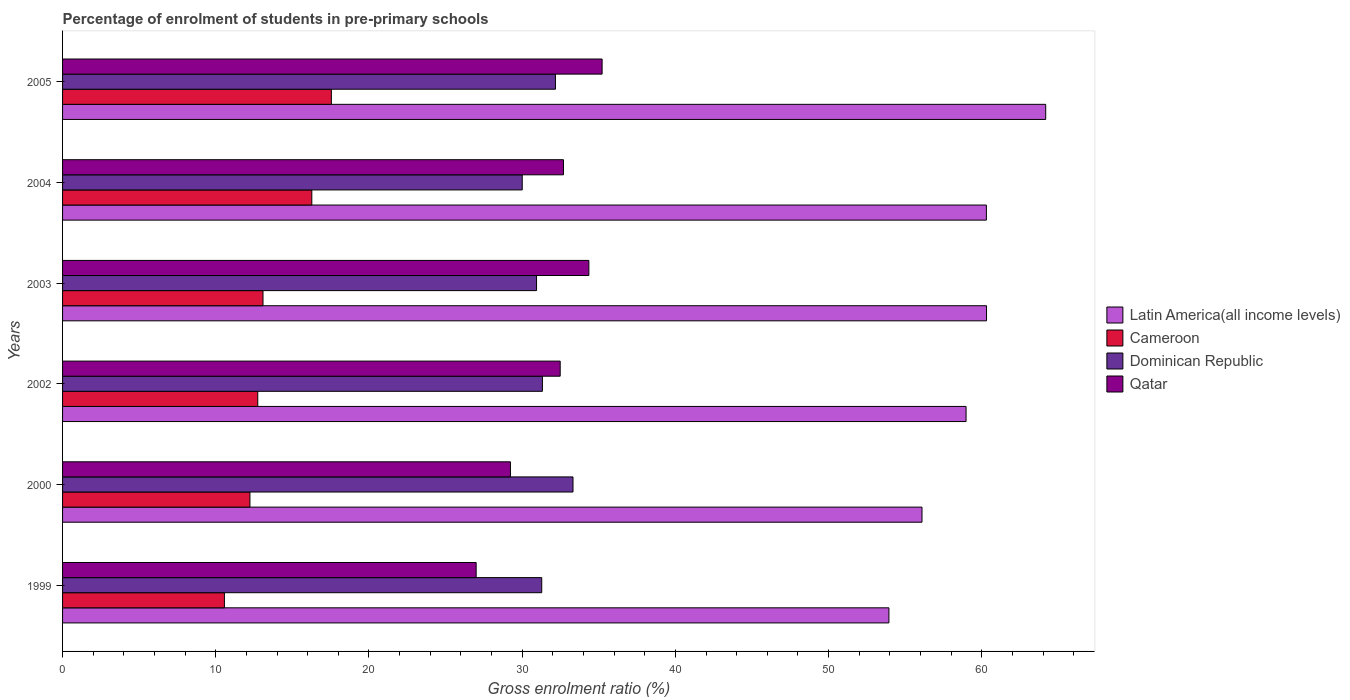How many groups of bars are there?
Your answer should be very brief. 6. Are the number of bars per tick equal to the number of legend labels?
Offer a terse response. Yes. Are the number of bars on each tick of the Y-axis equal?
Your answer should be compact. Yes. How many bars are there on the 1st tick from the top?
Offer a very short reply. 4. How many bars are there on the 1st tick from the bottom?
Provide a succinct answer. 4. What is the label of the 4th group of bars from the top?
Offer a very short reply. 2002. In how many cases, is the number of bars for a given year not equal to the number of legend labels?
Ensure brevity in your answer.  0. What is the percentage of students enrolled in pre-primary schools in Cameroon in 1999?
Ensure brevity in your answer.  10.56. Across all years, what is the maximum percentage of students enrolled in pre-primary schools in Dominican Republic?
Make the answer very short. 33.32. Across all years, what is the minimum percentage of students enrolled in pre-primary schools in Latin America(all income levels)?
Offer a very short reply. 53.94. What is the total percentage of students enrolled in pre-primary schools in Latin America(all income levels) in the graph?
Ensure brevity in your answer.  353.81. What is the difference between the percentage of students enrolled in pre-primary schools in Cameroon in 1999 and that in 2000?
Offer a terse response. -1.67. What is the difference between the percentage of students enrolled in pre-primary schools in Cameroon in 2005 and the percentage of students enrolled in pre-primary schools in Qatar in 2003?
Give a very brief answer. -16.81. What is the average percentage of students enrolled in pre-primary schools in Dominican Republic per year?
Your response must be concise. 31.51. In the year 2002, what is the difference between the percentage of students enrolled in pre-primary schools in Latin America(all income levels) and percentage of students enrolled in pre-primary schools in Cameroon?
Give a very brief answer. 46.23. In how many years, is the percentage of students enrolled in pre-primary schools in Latin America(all income levels) greater than 62 %?
Keep it short and to the point. 1. What is the ratio of the percentage of students enrolled in pre-primary schools in Latin America(all income levels) in 1999 to that in 2000?
Make the answer very short. 0.96. Is the difference between the percentage of students enrolled in pre-primary schools in Latin America(all income levels) in 1999 and 2002 greater than the difference between the percentage of students enrolled in pre-primary schools in Cameroon in 1999 and 2002?
Your answer should be very brief. No. What is the difference between the highest and the second highest percentage of students enrolled in pre-primary schools in Dominican Republic?
Provide a succinct answer. 1.15. What is the difference between the highest and the lowest percentage of students enrolled in pre-primary schools in Latin America(all income levels)?
Your answer should be very brief. 10.23. In how many years, is the percentage of students enrolled in pre-primary schools in Latin America(all income levels) greater than the average percentage of students enrolled in pre-primary schools in Latin America(all income levels) taken over all years?
Keep it short and to the point. 4. Is it the case that in every year, the sum of the percentage of students enrolled in pre-primary schools in Dominican Republic and percentage of students enrolled in pre-primary schools in Cameroon is greater than the sum of percentage of students enrolled in pre-primary schools in Qatar and percentage of students enrolled in pre-primary schools in Latin America(all income levels)?
Keep it short and to the point. Yes. What does the 2nd bar from the top in 2002 represents?
Make the answer very short. Dominican Republic. What does the 1st bar from the bottom in 2003 represents?
Offer a terse response. Latin America(all income levels). How many years are there in the graph?
Make the answer very short. 6. What is the difference between two consecutive major ticks on the X-axis?
Offer a terse response. 10. Are the values on the major ticks of X-axis written in scientific E-notation?
Provide a short and direct response. No. Does the graph contain any zero values?
Provide a succinct answer. No. What is the title of the graph?
Your answer should be very brief. Percentage of enrolment of students in pre-primary schools. What is the label or title of the X-axis?
Your answer should be compact. Gross enrolment ratio (%). What is the Gross enrolment ratio (%) in Latin America(all income levels) in 1999?
Your answer should be compact. 53.94. What is the Gross enrolment ratio (%) of Cameroon in 1999?
Offer a very short reply. 10.56. What is the Gross enrolment ratio (%) in Dominican Republic in 1999?
Provide a short and direct response. 31.28. What is the Gross enrolment ratio (%) of Qatar in 1999?
Keep it short and to the point. 27. What is the Gross enrolment ratio (%) in Latin America(all income levels) in 2000?
Make the answer very short. 56.1. What is the Gross enrolment ratio (%) in Cameroon in 2000?
Make the answer very short. 12.23. What is the Gross enrolment ratio (%) of Dominican Republic in 2000?
Provide a short and direct response. 33.32. What is the Gross enrolment ratio (%) of Qatar in 2000?
Offer a very short reply. 29.23. What is the Gross enrolment ratio (%) of Latin America(all income levels) in 2002?
Ensure brevity in your answer.  58.98. What is the Gross enrolment ratio (%) in Cameroon in 2002?
Offer a terse response. 12.74. What is the Gross enrolment ratio (%) in Dominican Republic in 2002?
Your answer should be very brief. 31.32. What is the Gross enrolment ratio (%) in Qatar in 2002?
Your answer should be very brief. 32.48. What is the Gross enrolment ratio (%) of Latin America(all income levels) in 2003?
Your answer should be very brief. 60.31. What is the Gross enrolment ratio (%) of Cameroon in 2003?
Your response must be concise. 13.08. What is the Gross enrolment ratio (%) in Dominican Republic in 2003?
Offer a terse response. 30.94. What is the Gross enrolment ratio (%) of Qatar in 2003?
Your answer should be compact. 34.35. What is the Gross enrolment ratio (%) in Latin America(all income levels) in 2004?
Give a very brief answer. 60.3. What is the Gross enrolment ratio (%) of Cameroon in 2004?
Offer a very short reply. 16.27. What is the Gross enrolment ratio (%) of Dominican Republic in 2004?
Your answer should be compact. 30. What is the Gross enrolment ratio (%) of Qatar in 2004?
Offer a terse response. 32.7. What is the Gross enrolment ratio (%) of Latin America(all income levels) in 2005?
Keep it short and to the point. 64.17. What is the Gross enrolment ratio (%) in Cameroon in 2005?
Offer a very short reply. 17.55. What is the Gross enrolment ratio (%) of Dominican Republic in 2005?
Provide a succinct answer. 32.17. What is the Gross enrolment ratio (%) in Qatar in 2005?
Keep it short and to the point. 35.22. Across all years, what is the maximum Gross enrolment ratio (%) of Latin America(all income levels)?
Offer a very short reply. 64.17. Across all years, what is the maximum Gross enrolment ratio (%) in Cameroon?
Offer a terse response. 17.55. Across all years, what is the maximum Gross enrolment ratio (%) in Dominican Republic?
Provide a succinct answer. 33.32. Across all years, what is the maximum Gross enrolment ratio (%) in Qatar?
Your answer should be very brief. 35.22. Across all years, what is the minimum Gross enrolment ratio (%) of Latin America(all income levels)?
Keep it short and to the point. 53.94. Across all years, what is the minimum Gross enrolment ratio (%) of Cameroon?
Offer a terse response. 10.56. Across all years, what is the minimum Gross enrolment ratio (%) of Dominican Republic?
Provide a succinct answer. 30. Across all years, what is the minimum Gross enrolment ratio (%) in Qatar?
Your answer should be very brief. 27. What is the total Gross enrolment ratio (%) in Latin America(all income levels) in the graph?
Offer a terse response. 353.81. What is the total Gross enrolment ratio (%) in Cameroon in the graph?
Provide a succinct answer. 82.44. What is the total Gross enrolment ratio (%) in Dominican Republic in the graph?
Make the answer very short. 189.04. What is the total Gross enrolment ratio (%) of Qatar in the graph?
Give a very brief answer. 190.98. What is the difference between the Gross enrolment ratio (%) in Latin America(all income levels) in 1999 and that in 2000?
Your answer should be very brief. -2.16. What is the difference between the Gross enrolment ratio (%) of Cameroon in 1999 and that in 2000?
Make the answer very short. -1.67. What is the difference between the Gross enrolment ratio (%) of Dominican Republic in 1999 and that in 2000?
Your response must be concise. -2.04. What is the difference between the Gross enrolment ratio (%) of Qatar in 1999 and that in 2000?
Ensure brevity in your answer.  -2.24. What is the difference between the Gross enrolment ratio (%) in Latin America(all income levels) in 1999 and that in 2002?
Your response must be concise. -5.03. What is the difference between the Gross enrolment ratio (%) of Cameroon in 1999 and that in 2002?
Provide a succinct answer. -2.18. What is the difference between the Gross enrolment ratio (%) of Dominican Republic in 1999 and that in 2002?
Your answer should be compact. -0.04. What is the difference between the Gross enrolment ratio (%) of Qatar in 1999 and that in 2002?
Offer a very short reply. -5.48. What is the difference between the Gross enrolment ratio (%) in Latin America(all income levels) in 1999 and that in 2003?
Provide a succinct answer. -6.37. What is the difference between the Gross enrolment ratio (%) in Cameroon in 1999 and that in 2003?
Your response must be concise. -2.52. What is the difference between the Gross enrolment ratio (%) of Dominican Republic in 1999 and that in 2003?
Offer a very short reply. 0.34. What is the difference between the Gross enrolment ratio (%) of Qatar in 1999 and that in 2003?
Your answer should be very brief. -7.36. What is the difference between the Gross enrolment ratio (%) of Latin America(all income levels) in 1999 and that in 2004?
Give a very brief answer. -6.36. What is the difference between the Gross enrolment ratio (%) in Cameroon in 1999 and that in 2004?
Offer a very short reply. -5.7. What is the difference between the Gross enrolment ratio (%) of Dominican Republic in 1999 and that in 2004?
Provide a short and direct response. 1.27. What is the difference between the Gross enrolment ratio (%) of Qatar in 1999 and that in 2004?
Make the answer very short. -5.7. What is the difference between the Gross enrolment ratio (%) of Latin America(all income levels) in 1999 and that in 2005?
Provide a succinct answer. -10.23. What is the difference between the Gross enrolment ratio (%) in Cameroon in 1999 and that in 2005?
Make the answer very short. -6.98. What is the difference between the Gross enrolment ratio (%) of Dominican Republic in 1999 and that in 2005?
Offer a terse response. -0.9. What is the difference between the Gross enrolment ratio (%) in Qatar in 1999 and that in 2005?
Your answer should be compact. -8.22. What is the difference between the Gross enrolment ratio (%) in Latin America(all income levels) in 2000 and that in 2002?
Keep it short and to the point. -2.88. What is the difference between the Gross enrolment ratio (%) in Cameroon in 2000 and that in 2002?
Offer a terse response. -0.51. What is the difference between the Gross enrolment ratio (%) in Dominican Republic in 2000 and that in 2002?
Provide a succinct answer. 2. What is the difference between the Gross enrolment ratio (%) in Qatar in 2000 and that in 2002?
Your response must be concise. -3.25. What is the difference between the Gross enrolment ratio (%) of Latin America(all income levels) in 2000 and that in 2003?
Give a very brief answer. -4.21. What is the difference between the Gross enrolment ratio (%) in Cameroon in 2000 and that in 2003?
Your response must be concise. -0.85. What is the difference between the Gross enrolment ratio (%) in Dominican Republic in 2000 and that in 2003?
Provide a short and direct response. 2.38. What is the difference between the Gross enrolment ratio (%) in Qatar in 2000 and that in 2003?
Your response must be concise. -5.12. What is the difference between the Gross enrolment ratio (%) of Latin America(all income levels) in 2000 and that in 2004?
Provide a short and direct response. -4.2. What is the difference between the Gross enrolment ratio (%) in Cameroon in 2000 and that in 2004?
Offer a very short reply. -4.04. What is the difference between the Gross enrolment ratio (%) in Dominican Republic in 2000 and that in 2004?
Your response must be concise. 3.31. What is the difference between the Gross enrolment ratio (%) in Qatar in 2000 and that in 2004?
Keep it short and to the point. -3.46. What is the difference between the Gross enrolment ratio (%) in Latin America(all income levels) in 2000 and that in 2005?
Give a very brief answer. -8.08. What is the difference between the Gross enrolment ratio (%) of Cameroon in 2000 and that in 2005?
Your response must be concise. -5.32. What is the difference between the Gross enrolment ratio (%) of Dominican Republic in 2000 and that in 2005?
Provide a short and direct response. 1.15. What is the difference between the Gross enrolment ratio (%) of Qatar in 2000 and that in 2005?
Provide a short and direct response. -5.98. What is the difference between the Gross enrolment ratio (%) of Latin America(all income levels) in 2002 and that in 2003?
Give a very brief answer. -1.34. What is the difference between the Gross enrolment ratio (%) in Cameroon in 2002 and that in 2003?
Ensure brevity in your answer.  -0.34. What is the difference between the Gross enrolment ratio (%) in Dominican Republic in 2002 and that in 2003?
Offer a terse response. 0.38. What is the difference between the Gross enrolment ratio (%) of Qatar in 2002 and that in 2003?
Your answer should be compact. -1.87. What is the difference between the Gross enrolment ratio (%) in Latin America(all income levels) in 2002 and that in 2004?
Your response must be concise. -1.33. What is the difference between the Gross enrolment ratio (%) in Cameroon in 2002 and that in 2004?
Provide a short and direct response. -3.53. What is the difference between the Gross enrolment ratio (%) in Dominican Republic in 2002 and that in 2004?
Your answer should be very brief. 1.32. What is the difference between the Gross enrolment ratio (%) in Qatar in 2002 and that in 2004?
Keep it short and to the point. -0.21. What is the difference between the Gross enrolment ratio (%) in Latin America(all income levels) in 2002 and that in 2005?
Give a very brief answer. -5.2. What is the difference between the Gross enrolment ratio (%) of Cameroon in 2002 and that in 2005?
Make the answer very short. -4.8. What is the difference between the Gross enrolment ratio (%) in Dominican Republic in 2002 and that in 2005?
Make the answer very short. -0.85. What is the difference between the Gross enrolment ratio (%) in Qatar in 2002 and that in 2005?
Provide a short and direct response. -2.74. What is the difference between the Gross enrolment ratio (%) of Latin America(all income levels) in 2003 and that in 2004?
Offer a terse response. 0.01. What is the difference between the Gross enrolment ratio (%) of Cameroon in 2003 and that in 2004?
Keep it short and to the point. -3.19. What is the difference between the Gross enrolment ratio (%) of Dominican Republic in 2003 and that in 2004?
Your answer should be very brief. 0.93. What is the difference between the Gross enrolment ratio (%) of Qatar in 2003 and that in 2004?
Provide a short and direct response. 1.66. What is the difference between the Gross enrolment ratio (%) in Latin America(all income levels) in 2003 and that in 2005?
Your response must be concise. -3.86. What is the difference between the Gross enrolment ratio (%) of Cameroon in 2003 and that in 2005?
Provide a short and direct response. -4.46. What is the difference between the Gross enrolment ratio (%) of Dominican Republic in 2003 and that in 2005?
Provide a short and direct response. -1.23. What is the difference between the Gross enrolment ratio (%) of Qatar in 2003 and that in 2005?
Give a very brief answer. -0.86. What is the difference between the Gross enrolment ratio (%) in Latin America(all income levels) in 2004 and that in 2005?
Ensure brevity in your answer.  -3.87. What is the difference between the Gross enrolment ratio (%) in Cameroon in 2004 and that in 2005?
Provide a succinct answer. -1.28. What is the difference between the Gross enrolment ratio (%) in Dominican Republic in 2004 and that in 2005?
Provide a succinct answer. -2.17. What is the difference between the Gross enrolment ratio (%) of Qatar in 2004 and that in 2005?
Your answer should be very brief. -2.52. What is the difference between the Gross enrolment ratio (%) of Latin America(all income levels) in 1999 and the Gross enrolment ratio (%) of Cameroon in 2000?
Your response must be concise. 41.71. What is the difference between the Gross enrolment ratio (%) of Latin America(all income levels) in 1999 and the Gross enrolment ratio (%) of Dominican Republic in 2000?
Give a very brief answer. 20.62. What is the difference between the Gross enrolment ratio (%) of Latin America(all income levels) in 1999 and the Gross enrolment ratio (%) of Qatar in 2000?
Your answer should be compact. 24.71. What is the difference between the Gross enrolment ratio (%) of Cameroon in 1999 and the Gross enrolment ratio (%) of Dominican Republic in 2000?
Make the answer very short. -22.75. What is the difference between the Gross enrolment ratio (%) in Cameroon in 1999 and the Gross enrolment ratio (%) in Qatar in 2000?
Give a very brief answer. -18.67. What is the difference between the Gross enrolment ratio (%) of Dominican Republic in 1999 and the Gross enrolment ratio (%) of Qatar in 2000?
Your answer should be compact. 2.04. What is the difference between the Gross enrolment ratio (%) in Latin America(all income levels) in 1999 and the Gross enrolment ratio (%) in Cameroon in 2002?
Your answer should be very brief. 41.2. What is the difference between the Gross enrolment ratio (%) in Latin America(all income levels) in 1999 and the Gross enrolment ratio (%) in Dominican Republic in 2002?
Offer a terse response. 22.62. What is the difference between the Gross enrolment ratio (%) of Latin America(all income levels) in 1999 and the Gross enrolment ratio (%) of Qatar in 2002?
Offer a terse response. 21.46. What is the difference between the Gross enrolment ratio (%) in Cameroon in 1999 and the Gross enrolment ratio (%) in Dominican Republic in 2002?
Provide a succinct answer. -20.76. What is the difference between the Gross enrolment ratio (%) in Cameroon in 1999 and the Gross enrolment ratio (%) in Qatar in 2002?
Ensure brevity in your answer.  -21.92. What is the difference between the Gross enrolment ratio (%) in Dominican Republic in 1999 and the Gross enrolment ratio (%) in Qatar in 2002?
Ensure brevity in your answer.  -1.2. What is the difference between the Gross enrolment ratio (%) of Latin America(all income levels) in 1999 and the Gross enrolment ratio (%) of Cameroon in 2003?
Provide a short and direct response. 40.86. What is the difference between the Gross enrolment ratio (%) in Latin America(all income levels) in 1999 and the Gross enrolment ratio (%) in Dominican Republic in 2003?
Provide a short and direct response. 23. What is the difference between the Gross enrolment ratio (%) of Latin America(all income levels) in 1999 and the Gross enrolment ratio (%) of Qatar in 2003?
Make the answer very short. 19.59. What is the difference between the Gross enrolment ratio (%) in Cameroon in 1999 and the Gross enrolment ratio (%) in Dominican Republic in 2003?
Keep it short and to the point. -20.37. What is the difference between the Gross enrolment ratio (%) in Cameroon in 1999 and the Gross enrolment ratio (%) in Qatar in 2003?
Provide a short and direct response. -23.79. What is the difference between the Gross enrolment ratio (%) of Dominican Republic in 1999 and the Gross enrolment ratio (%) of Qatar in 2003?
Keep it short and to the point. -3.08. What is the difference between the Gross enrolment ratio (%) of Latin America(all income levels) in 1999 and the Gross enrolment ratio (%) of Cameroon in 2004?
Offer a very short reply. 37.67. What is the difference between the Gross enrolment ratio (%) in Latin America(all income levels) in 1999 and the Gross enrolment ratio (%) in Dominican Republic in 2004?
Offer a terse response. 23.94. What is the difference between the Gross enrolment ratio (%) in Latin America(all income levels) in 1999 and the Gross enrolment ratio (%) in Qatar in 2004?
Your response must be concise. 21.24. What is the difference between the Gross enrolment ratio (%) in Cameroon in 1999 and the Gross enrolment ratio (%) in Dominican Republic in 2004?
Keep it short and to the point. -19.44. What is the difference between the Gross enrolment ratio (%) of Cameroon in 1999 and the Gross enrolment ratio (%) of Qatar in 2004?
Offer a terse response. -22.13. What is the difference between the Gross enrolment ratio (%) of Dominican Republic in 1999 and the Gross enrolment ratio (%) of Qatar in 2004?
Give a very brief answer. -1.42. What is the difference between the Gross enrolment ratio (%) of Latin America(all income levels) in 1999 and the Gross enrolment ratio (%) of Cameroon in 2005?
Give a very brief answer. 36.4. What is the difference between the Gross enrolment ratio (%) of Latin America(all income levels) in 1999 and the Gross enrolment ratio (%) of Dominican Republic in 2005?
Offer a very short reply. 21.77. What is the difference between the Gross enrolment ratio (%) of Latin America(all income levels) in 1999 and the Gross enrolment ratio (%) of Qatar in 2005?
Provide a succinct answer. 18.72. What is the difference between the Gross enrolment ratio (%) of Cameroon in 1999 and the Gross enrolment ratio (%) of Dominican Republic in 2005?
Keep it short and to the point. -21.61. What is the difference between the Gross enrolment ratio (%) in Cameroon in 1999 and the Gross enrolment ratio (%) in Qatar in 2005?
Ensure brevity in your answer.  -24.65. What is the difference between the Gross enrolment ratio (%) in Dominican Republic in 1999 and the Gross enrolment ratio (%) in Qatar in 2005?
Keep it short and to the point. -3.94. What is the difference between the Gross enrolment ratio (%) of Latin America(all income levels) in 2000 and the Gross enrolment ratio (%) of Cameroon in 2002?
Make the answer very short. 43.36. What is the difference between the Gross enrolment ratio (%) in Latin America(all income levels) in 2000 and the Gross enrolment ratio (%) in Dominican Republic in 2002?
Provide a short and direct response. 24.78. What is the difference between the Gross enrolment ratio (%) of Latin America(all income levels) in 2000 and the Gross enrolment ratio (%) of Qatar in 2002?
Offer a very short reply. 23.62. What is the difference between the Gross enrolment ratio (%) in Cameroon in 2000 and the Gross enrolment ratio (%) in Dominican Republic in 2002?
Your answer should be compact. -19.09. What is the difference between the Gross enrolment ratio (%) in Cameroon in 2000 and the Gross enrolment ratio (%) in Qatar in 2002?
Give a very brief answer. -20.25. What is the difference between the Gross enrolment ratio (%) in Dominican Republic in 2000 and the Gross enrolment ratio (%) in Qatar in 2002?
Keep it short and to the point. 0.84. What is the difference between the Gross enrolment ratio (%) of Latin America(all income levels) in 2000 and the Gross enrolment ratio (%) of Cameroon in 2003?
Give a very brief answer. 43.02. What is the difference between the Gross enrolment ratio (%) of Latin America(all income levels) in 2000 and the Gross enrolment ratio (%) of Dominican Republic in 2003?
Provide a short and direct response. 25.16. What is the difference between the Gross enrolment ratio (%) in Latin America(all income levels) in 2000 and the Gross enrolment ratio (%) in Qatar in 2003?
Your answer should be compact. 21.74. What is the difference between the Gross enrolment ratio (%) of Cameroon in 2000 and the Gross enrolment ratio (%) of Dominican Republic in 2003?
Keep it short and to the point. -18.71. What is the difference between the Gross enrolment ratio (%) of Cameroon in 2000 and the Gross enrolment ratio (%) of Qatar in 2003?
Your response must be concise. -22.12. What is the difference between the Gross enrolment ratio (%) in Dominican Republic in 2000 and the Gross enrolment ratio (%) in Qatar in 2003?
Your response must be concise. -1.04. What is the difference between the Gross enrolment ratio (%) in Latin America(all income levels) in 2000 and the Gross enrolment ratio (%) in Cameroon in 2004?
Your response must be concise. 39.83. What is the difference between the Gross enrolment ratio (%) in Latin America(all income levels) in 2000 and the Gross enrolment ratio (%) in Dominican Republic in 2004?
Your response must be concise. 26.09. What is the difference between the Gross enrolment ratio (%) in Latin America(all income levels) in 2000 and the Gross enrolment ratio (%) in Qatar in 2004?
Make the answer very short. 23.4. What is the difference between the Gross enrolment ratio (%) in Cameroon in 2000 and the Gross enrolment ratio (%) in Dominican Republic in 2004?
Provide a succinct answer. -17.77. What is the difference between the Gross enrolment ratio (%) of Cameroon in 2000 and the Gross enrolment ratio (%) of Qatar in 2004?
Keep it short and to the point. -20.47. What is the difference between the Gross enrolment ratio (%) of Dominican Republic in 2000 and the Gross enrolment ratio (%) of Qatar in 2004?
Offer a terse response. 0.62. What is the difference between the Gross enrolment ratio (%) in Latin America(all income levels) in 2000 and the Gross enrolment ratio (%) in Cameroon in 2005?
Your answer should be compact. 38.55. What is the difference between the Gross enrolment ratio (%) of Latin America(all income levels) in 2000 and the Gross enrolment ratio (%) of Dominican Republic in 2005?
Offer a very short reply. 23.93. What is the difference between the Gross enrolment ratio (%) of Latin America(all income levels) in 2000 and the Gross enrolment ratio (%) of Qatar in 2005?
Your response must be concise. 20.88. What is the difference between the Gross enrolment ratio (%) of Cameroon in 2000 and the Gross enrolment ratio (%) of Dominican Republic in 2005?
Give a very brief answer. -19.94. What is the difference between the Gross enrolment ratio (%) of Cameroon in 2000 and the Gross enrolment ratio (%) of Qatar in 2005?
Offer a terse response. -22.99. What is the difference between the Gross enrolment ratio (%) in Latin America(all income levels) in 2002 and the Gross enrolment ratio (%) in Cameroon in 2003?
Provide a short and direct response. 45.89. What is the difference between the Gross enrolment ratio (%) in Latin America(all income levels) in 2002 and the Gross enrolment ratio (%) in Dominican Republic in 2003?
Keep it short and to the point. 28.04. What is the difference between the Gross enrolment ratio (%) of Latin America(all income levels) in 2002 and the Gross enrolment ratio (%) of Qatar in 2003?
Keep it short and to the point. 24.62. What is the difference between the Gross enrolment ratio (%) in Cameroon in 2002 and the Gross enrolment ratio (%) in Dominican Republic in 2003?
Your answer should be compact. -18.2. What is the difference between the Gross enrolment ratio (%) in Cameroon in 2002 and the Gross enrolment ratio (%) in Qatar in 2003?
Provide a succinct answer. -21.61. What is the difference between the Gross enrolment ratio (%) in Dominican Republic in 2002 and the Gross enrolment ratio (%) in Qatar in 2003?
Give a very brief answer. -3.03. What is the difference between the Gross enrolment ratio (%) of Latin America(all income levels) in 2002 and the Gross enrolment ratio (%) of Cameroon in 2004?
Your response must be concise. 42.71. What is the difference between the Gross enrolment ratio (%) in Latin America(all income levels) in 2002 and the Gross enrolment ratio (%) in Dominican Republic in 2004?
Offer a terse response. 28.97. What is the difference between the Gross enrolment ratio (%) in Latin America(all income levels) in 2002 and the Gross enrolment ratio (%) in Qatar in 2004?
Offer a terse response. 26.28. What is the difference between the Gross enrolment ratio (%) of Cameroon in 2002 and the Gross enrolment ratio (%) of Dominican Republic in 2004?
Ensure brevity in your answer.  -17.26. What is the difference between the Gross enrolment ratio (%) in Cameroon in 2002 and the Gross enrolment ratio (%) in Qatar in 2004?
Make the answer very short. -19.95. What is the difference between the Gross enrolment ratio (%) of Dominican Republic in 2002 and the Gross enrolment ratio (%) of Qatar in 2004?
Provide a short and direct response. -1.37. What is the difference between the Gross enrolment ratio (%) of Latin America(all income levels) in 2002 and the Gross enrolment ratio (%) of Cameroon in 2005?
Give a very brief answer. 41.43. What is the difference between the Gross enrolment ratio (%) in Latin America(all income levels) in 2002 and the Gross enrolment ratio (%) in Dominican Republic in 2005?
Provide a short and direct response. 26.8. What is the difference between the Gross enrolment ratio (%) in Latin America(all income levels) in 2002 and the Gross enrolment ratio (%) in Qatar in 2005?
Provide a short and direct response. 23.76. What is the difference between the Gross enrolment ratio (%) of Cameroon in 2002 and the Gross enrolment ratio (%) of Dominican Republic in 2005?
Offer a very short reply. -19.43. What is the difference between the Gross enrolment ratio (%) in Cameroon in 2002 and the Gross enrolment ratio (%) in Qatar in 2005?
Keep it short and to the point. -22.48. What is the difference between the Gross enrolment ratio (%) of Dominican Republic in 2002 and the Gross enrolment ratio (%) of Qatar in 2005?
Offer a terse response. -3.9. What is the difference between the Gross enrolment ratio (%) in Latin America(all income levels) in 2003 and the Gross enrolment ratio (%) in Cameroon in 2004?
Give a very brief answer. 44.04. What is the difference between the Gross enrolment ratio (%) in Latin America(all income levels) in 2003 and the Gross enrolment ratio (%) in Dominican Republic in 2004?
Ensure brevity in your answer.  30.31. What is the difference between the Gross enrolment ratio (%) of Latin America(all income levels) in 2003 and the Gross enrolment ratio (%) of Qatar in 2004?
Offer a very short reply. 27.62. What is the difference between the Gross enrolment ratio (%) of Cameroon in 2003 and the Gross enrolment ratio (%) of Dominican Republic in 2004?
Your answer should be very brief. -16.92. What is the difference between the Gross enrolment ratio (%) in Cameroon in 2003 and the Gross enrolment ratio (%) in Qatar in 2004?
Your response must be concise. -19.61. What is the difference between the Gross enrolment ratio (%) of Dominican Republic in 2003 and the Gross enrolment ratio (%) of Qatar in 2004?
Your answer should be very brief. -1.76. What is the difference between the Gross enrolment ratio (%) in Latin America(all income levels) in 2003 and the Gross enrolment ratio (%) in Cameroon in 2005?
Offer a terse response. 42.77. What is the difference between the Gross enrolment ratio (%) of Latin America(all income levels) in 2003 and the Gross enrolment ratio (%) of Dominican Republic in 2005?
Provide a succinct answer. 28.14. What is the difference between the Gross enrolment ratio (%) in Latin America(all income levels) in 2003 and the Gross enrolment ratio (%) in Qatar in 2005?
Ensure brevity in your answer.  25.09. What is the difference between the Gross enrolment ratio (%) of Cameroon in 2003 and the Gross enrolment ratio (%) of Dominican Republic in 2005?
Your answer should be very brief. -19.09. What is the difference between the Gross enrolment ratio (%) of Cameroon in 2003 and the Gross enrolment ratio (%) of Qatar in 2005?
Your response must be concise. -22.14. What is the difference between the Gross enrolment ratio (%) in Dominican Republic in 2003 and the Gross enrolment ratio (%) in Qatar in 2005?
Your answer should be very brief. -4.28. What is the difference between the Gross enrolment ratio (%) of Latin America(all income levels) in 2004 and the Gross enrolment ratio (%) of Cameroon in 2005?
Provide a short and direct response. 42.76. What is the difference between the Gross enrolment ratio (%) in Latin America(all income levels) in 2004 and the Gross enrolment ratio (%) in Dominican Republic in 2005?
Offer a very short reply. 28.13. What is the difference between the Gross enrolment ratio (%) in Latin America(all income levels) in 2004 and the Gross enrolment ratio (%) in Qatar in 2005?
Offer a very short reply. 25.08. What is the difference between the Gross enrolment ratio (%) of Cameroon in 2004 and the Gross enrolment ratio (%) of Dominican Republic in 2005?
Your answer should be compact. -15.9. What is the difference between the Gross enrolment ratio (%) of Cameroon in 2004 and the Gross enrolment ratio (%) of Qatar in 2005?
Your answer should be very brief. -18.95. What is the difference between the Gross enrolment ratio (%) in Dominican Republic in 2004 and the Gross enrolment ratio (%) in Qatar in 2005?
Offer a terse response. -5.21. What is the average Gross enrolment ratio (%) of Latin America(all income levels) per year?
Offer a very short reply. 58.97. What is the average Gross enrolment ratio (%) in Cameroon per year?
Provide a succinct answer. 13.74. What is the average Gross enrolment ratio (%) in Dominican Republic per year?
Give a very brief answer. 31.51. What is the average Gross enrolment ratio (%) of Qatar per year?
Offer a terse response. 31.83. In the year 1999, what is the difference between the Gross enrolment ratio (%) of Latin America(all income levels) and Gross enrolment ratio (%) of Cameroon?
Make the answer very short. 43.38. In the year 1999, what is the difference between the Gross enrolment ratio (%) in Latin America(all income levels) and Gross enrolment ratio (%) in Dominican Republic?
Your response must be concise. 22.66. In the year 1999, what is the difference between the Gross enrolment ratio (%) in Latin America(all income levels) and Gross enrolment ratio (%) in Qatar?
Offer a terse response. 26.94. In the year 1999, what is the difference between the Gross enrolment ratio (%) of Cameroon and Gross enrolment ratio (%) of Dominican Republic?
Your answer should be very brief. -20.71. In the year 1999, what is the difference between the Gross enrolment ratio (%) in Cameroon and Gross enrolment ratio (%) in Qatar?
Provide a succinct answer. -16.43. In the year 1999, what is the difference between the Gross enrolment ratio (%) of Dominican Republic and Gross enrolment ratio (%) of Qatar?
Your answer should be very brief. 4.28. In the year 2000, what is the difference between the Gross enrolment ratio (%) of Latin America(all income levels) and Gross enrolment ratio (%) of Cameroon?
Offer a terse response. 43.87. In the year 2000, what is the difference between the Gross enrolment ratio (%) of Latin America(all income levels) and Gross enrolment ratio (%) of Dominican Republic?
Ensure brevity in your answer.  22.78. In the year 2000, what is the difference between the Gross enrolment ratio (%) of Latin America(all income levels) and Gross enrolment ratio (%) of Qatar?
Offer a very short reply. 26.86. In the year 2000, what is the difference between the Gross enrolment ratio (%) of Cameroon and Gross enrolment ratio (%) of Dominican Republic?
Your answer should be very brief. -21.09. In the year 2000, what is the difference between the Gross enrolment ratio (%) of Cameroon and Gross enrolment ratio (%) of Qatar?
Provide a succinct answer. -17. In the year 2000, what is the difference between the Gross enrolment ratio (%) of Dominican Republic and Gross enrolment ratio (%) of Qatar?
Provide a short and direct response. 4.08. In the year 2002, what is the difference between the Gross enrolment ratio (%) in Latin America(all income levels) and Gross enrolment ratio (%) in Cameroon?
Ensure brevity in your answer.  46.23. In the year 2002, what is the difference between the Gross enrolment ratio (%) in Latin America(all income levels) and Gross enrolment ratio (%) in Dominican Republic?
Make the answer very short. 27.65. In the year 2002, what is the difference between the Gross enrolment ratio (%) of Latin America(all income levels) and Gross enrolment ratio (%) of Qatar?
Offer a very short reply. 26.49. In the year 2002, what is the difference between the Gross enrolment ratio (%) of Cameroon and Gross enrolment ratio (%) of Dominican Republic?
Provide a short and direct response. -18.58. In the year 2002, what is the difference between the Gross enrolment ratio (%) of Cameroon and Gross enrolment ratio (%) of Qatar?
Provide a short and direct response. -19.74. In the year 2002, what is the difference between the Gross enrolment ratio (%) in Dominican Republic and Gross enrolment ratio (%) in Qatar?
Keep it short and to the point. -1.16. In the year 2003, what is the difference between the Gross enrolment ratio (%) of Latin America(all income levels) and Gross enrolment ratio (%) of Cameroon?
Your answer should be compact. 47.23. In the year 2003, what is the difference between the Gross enrolment ratio (%) of Latin America(all income levels) and Gross enrolment ratio (%) of Dominican Republic?
Make the answer very short. 29.37. In the year 2003, what is the difference between the Gross enrolment ratio (%) of Latin America(all income levels) and Gross enrolment ratio (%) of Qatar?
Provide a succinct answer. 25.96. In the year 2003, what is the difference between the Gross enrolment ratio (%) of Cameroon and Gross enrolment ratio (%) of Dominican Republic?
Offer a terse response. -17.86. In the year 2003, what is the difference between the Gross enrolment ratio (%) in Cameroon and Gross enrolment ratio (%) in Qatar?
Your answer should be compact. -21.27. In the year 2003, what is the difference between the Gross enrolment ratio (%) of Dominican Republic and Gross enrolment ratio (%) of Qatar?
Your response must be concise. -3.42. In the year 2004, what is the difference between the Gross enrolment ratio (%) of Latin America(all income levels) and Gross enrolment ratio (%) of Cameroon?
Offer a terse response. 44.03. In the year 2004, what is the difference between the Gross enrolment ratio (%) of Latin America(all income levels) and Gross enrolment ratio (%) of Dominican Republic?
Your response must be concise. 30.3. In the year 2004, what is the difference between the Gross enrolment ratio (%) in Latin America(all income levels) and Gross enrolment ratio (%) in Qatar?
Ensure brevity in your answer.  27.61. In the year 2004, what is the difference between the Gross enrolment ratio (%) of Cameroon and Gross enrolment ratio (%) of Dominican Republic?
Offer a terse response. -13.74. In the year 2004, what is the difference between the Gross enrolment ratio (%) of Cameroon and Gross enrolment ratio (%) of Qatar?
Provide a short and direct response. -16.43. In the year 2004, what is the difference between the Gross enrolment ratio (%) in Dominican Republic and Gross enrolment ratio (%) in Qatar?
Offer a very short reply. -2.69. In the year 2005, what is the difference between the Gross enrolment ratio (%) in Latin America(all income levels) and Gross enrolment ratio (%) in Cameroon?
Give a very brief answer. 46.63. In the year 2005, what is the difference between the Gross enrolment ratio (%) of Latin America(all income levels) and Gross enrolment ratio (%) of Dominican Republic?
Keep it short and to the point. 32. In the year 2005, what is the difference between the Gross enrolment ratio (%) in Latin America(all income levels) and Gross enrolment ratio (%) in Qatar?
Give a very brief answer. 28.96. In the year 2005, what is the difference between the Gross enrolment ratio (%) of Cameroon and Gross enrolment ratio (%) of Dominican Republic?
Your response must be concise. -14.63. In the year 2005, what is the difference between the Gross enrolment ratio (%) in Cameroon and Gross enrolment ratio (%) in Qatar?
Offer a terse response. -17.67. In the year 2005, what is the difference between the Gross enrolment ratio (%) of Dominican Republic and Gross enrolment ratio (%) of Qatar?
Provide a succinct answer. -3.05. What is the ratio of the Gross enrolment ratio (%) of Latin America(all income levels) in 1999 to that in 2000?
Offer a terse response. 0.96. What is the ratio of the Gross enrolment ratio (%) of Cameroon in 1999 to that in 2000?
Offer a very short reply. 0.86. What is the ratio of the Gross enrolment ratio (%) in Dominican Republic in 1999 to that in 2000?
Your response must be concise. 0.94. What is the ratio of the Gross enrolment ratio (%) of Qatar in 1999 to that in 2000?
Keep it short and to the point. 0.92. What is the ratio of the Gross enrolment ratio (%) in Latin America(all income levels) in 1999 to that in 2002?
Provide a succinct answer. 0.91. What is the ratio of the Gross enrolment ratio (%) of Cameroon in 1999 to that in 2002?
Provide a succinct answer. 0.83. What is the ratio of the Gross enrolment ratio (%) of Dominican Republic in 1999 to that in 2002?
Offer a very short reply. 1. What is the ratio of the Gross enrolment ratio (%) in Qatar in 1999 to that in 2002?
Make the answer very short. 0.83. What is the ratio of the Gross enrolment ratio (%) in Latin America(all income levels) in 1999 to that in 2003?
Your response must be concise. 0.89. What is the ratio of the Gross enrolment ratio (%) of Cameroon in 1999 to that in 2003?
Your answer should be very brief. 0.81. What is the ratio of the Gross enrolment ratio (%) in Dominican Republic in 1999 to that in 2003?
Your answer should be compact. 1.01. What is the ratio of the Gross enrolment ratio (%) of Qatar in 1999 to that in 2003?
Offer a terse response. 0.79. What is the ratio of the Gross enrolment ratio (%) of Latin America(all income levels) in 1999 to that in 2004?
Give a very brief answer. 0.89. What is the ratio of the Gross enrolment ratio (%) in Cameroon in 1999 to that in 2004?
Offer a terse response. 0.65. What is the ratio of the Gross enrolment ratio (%) in Dominican Republic in 1999 to that in 2004?
Your answer should be very brief. 1.04. What is the ratio of the Gross enrolment ratio (%) in Qatar in 1999 to that in 2004?
Offer a very short reply. 0.83. What is the ratio of the Gross enrolment ratio (%) in Latin America(all income levels) in 1999 to that in 2005?
Offer a very short reply. 0.84. What is the ratio of the Gross enrolment ratio (%) of Cameroon in 1999 to that in 2005?
Your answer should be very brief. 0.6. What is the ratio of the Gross enrolment ratio (%) in Dominican Republic in 1999 to that in 2005?
Your answer should be compact. 0.97. What is the ratio of the Gross enrolment ratio (%) in Qatar in 1999 to that in 2005?
Make the answer very short. 0.77. What is the ratio of the Gross enrolment ratio (%) of Latin America(all income levels) in 2000 to that in 2002?
Provide a short and direct response. 0.95. What is the ratio of the Gross enrolment ratio (%) in Cameroon in 2000 to that in 2002?
Your answer should be compact. 0.96. What is the ratio of the Gross enrolment ratio (%) in Dominican Republic in 2000 to that in 2002?
Your response must be concise. 1.06. What is the ratio of the Gross enrolment ratio (%) in Latin America(all income levels) in 2000 to that in 2003?
Make the answer very short. 0.93. What is the ratio of the Gross enrolment ratio (%) in Cameroon in 2000 to that in 2003?
Provide a short and direct response. 0.93. What is the ratio of the Gross enrolment ratio (%) in Qatar in 2000 to that in 2003?
Make the answer very short. 0.85. What is the ratio of the Gross enrolment ratio (%) of Latin America(all income levels) in 2000 to that in 2004?
Your response must be concise. 0.93. What is the ratio of the Gross enrolment ratio (%) in Cameroon in 2000 to that in 2004?
Make the answer very short. 0.75. What is the ratio of the Gross enrolment ratio (%) of Dominican Republic in 2000 to that in 2004?
Offer a very short reply. 1.11. What is the ratio of the Gross enrolment ratio (%) in Qatar in 2000 to that in 2004?
Make the answer very short. 0.89. What is the ratio of the Gross enrolment ratio (%) in Latin America(all income levels) in 2000 to that in 2005?
Offer a very short reply. 0.87. What is the ratio of the Gross enrolment ratio (%) in Cameroon in 2000 to that in 2005?
Provide a short and direct response. 0.7. What is the ratio of the Gross enrolment ratio (%) of Dominican Republic in 2000 to that in 2005?
Offer a terse response. 1.04. What is the ratio of the Gross enrolment ratio (%) in Qatar in 2000 to that in 2005?
Make the answer very short. 0.83. What is the ratio of the Gross enrolment ratio (%) in Latin America(all income levels) in 2002 to that in 2003?
Your response must be concise. 0.98. What is the ratio of the Gross enrolment ratio (%) in Cameroon in 2002 to that in 2003?
Provide a short and direct response. 0.97. What is the ratio of the Gross enrolment ratio (%) in Dominican Republic in 2002 to that in 2003?
Make the answer very short. 1.01. What is the ratio of the Gross enrolment ratio (%) of Qatar in 2002 to that in 2003?
Ensure brevity in your answer.  0.95. What is the ratio of the Gross enrolment ratio (%) of Cameroon in 2002 to that in 2004?
Offer a terse response. 0.78. What is the ratio of the Gross enrolment ratio (%) in Dominican Republic in 2002 to that in 2004?
Ensure brevity in your answer.  1.04. What is the ratio of the Gross enrolment ratio (%) in Qatar in 2002 to that in 2004?
Make the answer very short. 0.99. What is the ratio of the Gross enrolment ratio (%) in Latin America(all income levels) in 2002 to that in 2005?
Ensure brevity in your answer.  0.92. What is the ratio of the Gross enrolment ratio (%) in Cameroon in 2002 to that in 2005?
Make the answer very short. 0.73. What is the ratio of the Gross enrolment ratio (%) in Dominican Republic in 2002 to that in 2005?
Provide a short and direct response. 0.97. What is the ratio of the Gross enrolment ratio (%) in Qatar in 2002 to that in 2005?
Your response must be concise. 0.92. What is the ratio of the Gross enrolment ratio (%) of Cameroon in 2003 to that in 2004?
Offer a terse response. 0.8. What is the ratio of the Gross enrolment ratio (%) in Dominican Republic in 2003 to that in 2004?
Make the answer very short. 1.03. What is the ratio of the Gross enrolment ratio (%) of Qatar in 2003 to that in 2004?
Provide a short and direct response. 1.05. What is the ratio of the Gross enrolment ratio (%) of Latin America(all income levels) in 2003 to that in 2005?
Give a very brief answer. 0.94. What is the ratio of the Gross enrolment ratio (%) of Cameroon in 2003 to that in 2005?
Offer a terse response. 0.75. What is the ratio of the Gross enrolment ratio (%) in Dominican Republic in 2003 to that in 2005?
Offer a terse response. 0.96. What is the ratio of the Gross enrolment ratio (%) in Qatar in 2003 to that in 2005?
Offer a very short reply. 0.98. What is the ratio of the Gross enrolment ratio (%) of Latin America(all income levels) in 2004 to that in 2005?
Give a very brief answer. 0.94. What is the ratio of the Gross enrolment ratio (%) of Cameroon in 2004 to that in 2005?
Your response must be concise. 0.93. What is the ratio of the Gross enrolment ratio (%) in Dominican Republic in 2004 to that in 2005?
Your answer should be very brief. 0.93. What is the ratio of the Gross enrolment ratio (%) in Qatar in 2004 to that in 2005?
Your answer should be compact. 0.93. What is the difference between the highest and the second highest Gross enrolment ratio (%) of Latin America(all income levels)?
Provide a succinct answer. 3.86. What is the difference between the highest and the second highest Gross enrolment ratio (%) of Cameroon?
Ensure brevity in your answer.  1.28. What is the difference between the highest and the second highest Gross enrolment ratio (%) in Dominican Republic?
Your answer should be compact. 1.15. What is the difference between the highest and the second highest Gross enrolment ratio (%) in Qatar?
Provide a succinct answer. 0.86. What is the difference between the highest and the lowest Gross enrolment ratio (%) of Latin America(all income levels)?
Provide a short and direct response. 10.23. What is the difference between the highest and the lowest Gross enrolment ratio (%) in Cameroon?
Offer a terse response. 6.98. What is the difference between the highest and the lowest Gross enrolment ratio (%) in Dominican Republic?
Your answer should be very brief. 3.31. What is the difference between the highest and the lowest Gross enrolment ratio (%) of Qatar?
Provide a succinct answer. 8.22. 